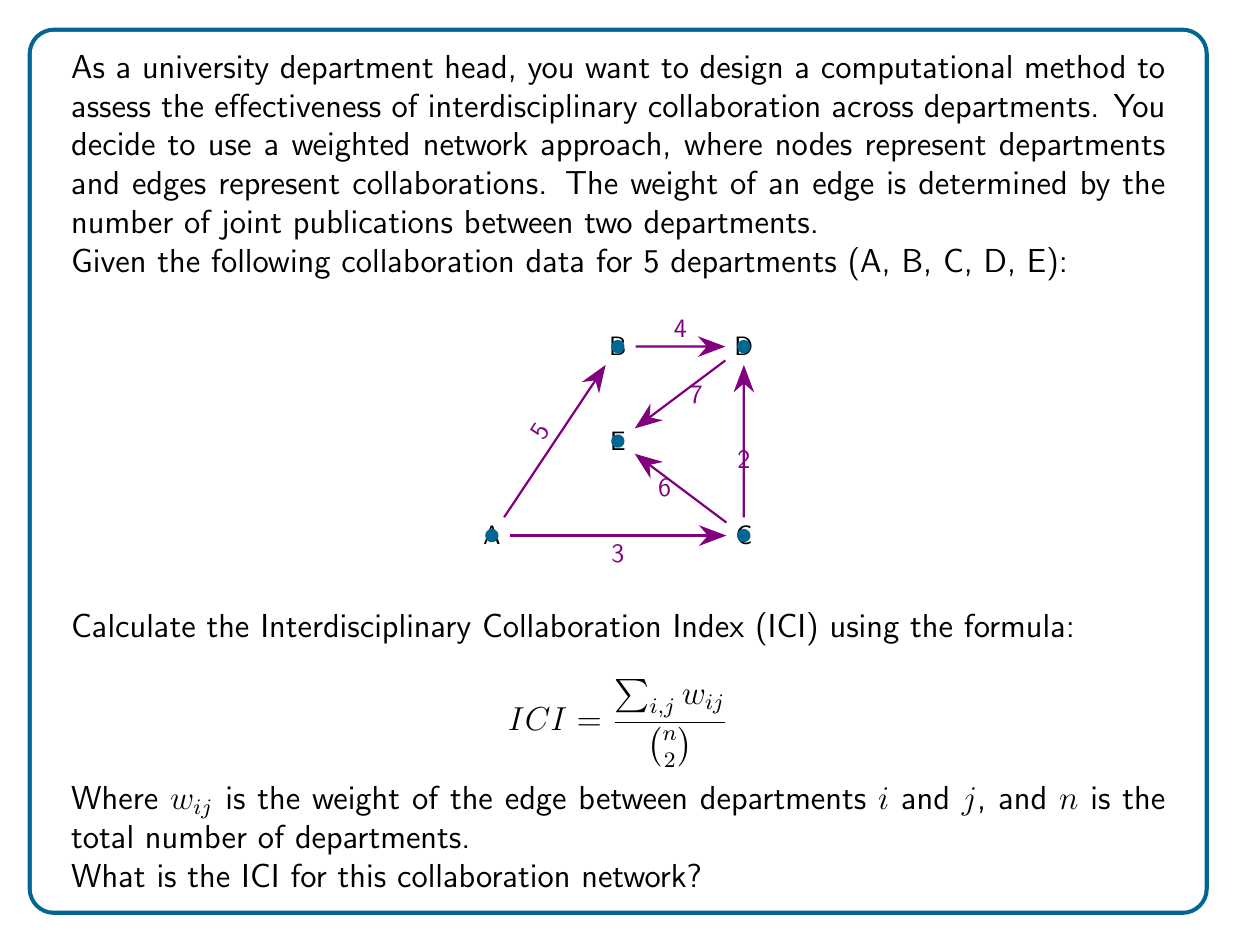What is the answer to this math problem? To calculate the Interdisciplinary Collaboration Index (ICI), we need to follow these steps:

1. Sum up all the weights of the edges in the network:
   $\sum_{i,j} w_{ij} = 5 + 3 + 4 + 2 + 6 + 7 = 27$

2. Calculate $\binom{n}{2}$, which represents the total number of possible connections in a network with $n$ nodes:
   $n = 5$ (total number of departments)
   $\binom{n}{2} = \frac{n(n-1)}{2} = \frac{5(5-1)}{2} = \frac{5 \times 4}{2} = 10$

3. Apply the ICI formula:
   $$ ICI = \frac{\sum_{i,j} w_{ij}}{\binom{n}{2}} = \frac{27}{10} = 2.7 $$

Therefore, the Interdisciplinary Collaboration Index (ICI) for this collaboration network is 2.7.
Answer: 2.7 